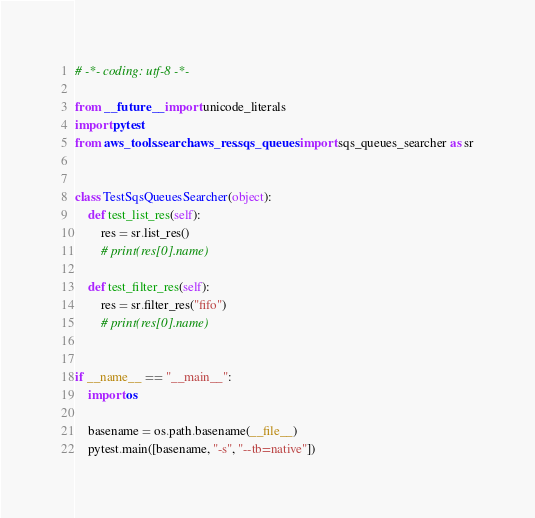<code> <loc_0><loc_0><loc_500><loc_500><_Python_># -*- coding: utf-8 -*-

from __future__ import unicode_literals
import pytest
from aws_tools.search.aws_res.sqs_queues import sqs_queues_searcher as sr


class TestSqsQueuesSearcher(object):
    def test_list_res(self):
        res = sr.list_res()
        # print(res[0].name)

    def test_filter_res(self):
        res = sr.filter_res("fifo")
        # print(res[0].name)


if __name__ == "__main__":
    import os

    basename = os.path.basename(__file__)
    pytest.main([basename, "-s", "--tb=native"])
</code> 